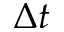<formula> <loc_0><loc_0><loc_500><loc_500>\Delta t</formula> 